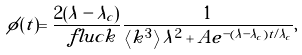Convert formula to latex. <formula><loc_0><loc_0><loc_500><loc_500>\phi ( t ) = \frac { 2 ( \lambda - \lambda _ { c } ) } { \ f l u c k } \frac { 1 } { \left < k ^ { 3 } \right > \lambda ^ { 2 } + A e ^ { - ( \lambda - \lambda _ { c } ) t / \lambda _ { c } } } ,</formula> 